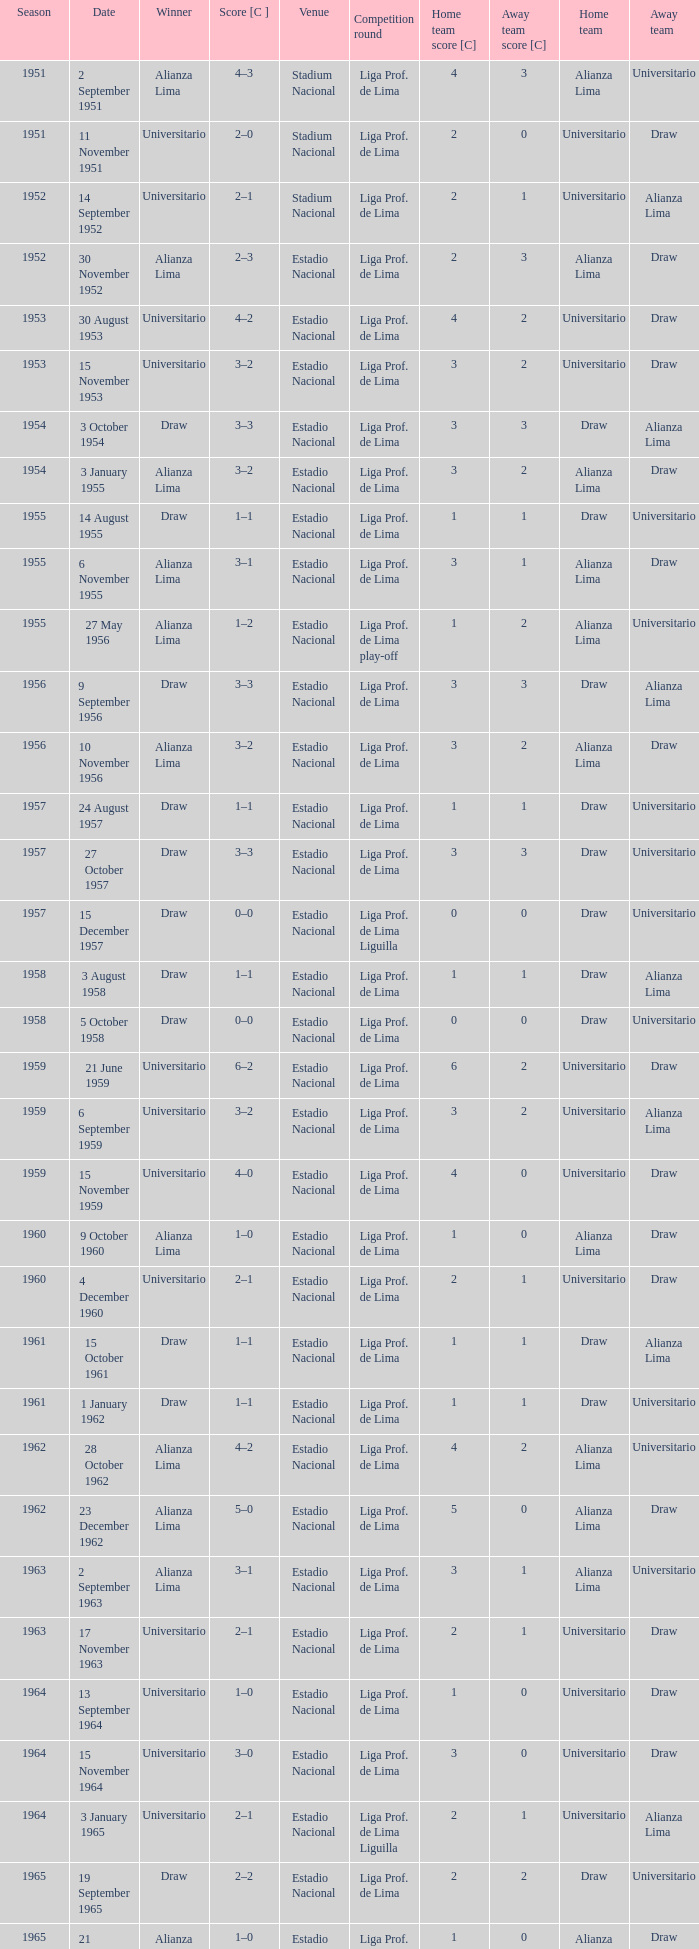I'm looking to parse the entire table for insights. Could you assist me with that? {'header': ['Season', 'Date', 'Winner', 'Score [C ]', 'Venue', 'Competition round', 'Home team score [C]', 'Away team score [C]', 'Home team', 'Away team'], 'rows': [['1951', '2 September 1951', 'Alianza Lima', '4–3', 'Stadium Nacional', 'Liga Prof. de Lima', '4', '3', 'Alianza Lima', 'Universitario'], ['1951', '11 November 1951', 'Universitario', '2–0', 'Stadium Nacional', 'Liga Prof. de Lima', '2', '0', 'Universitario', 'Draw'], ['1952', '14 September 1952', 'Universitario', '2–1', 'Stadium Nacional', 'Liga Prof. de Lima', '2', '1', 'Universitario', 'Alianza Lima'], ['1952', '30 November 1952', 'Alianza Lima', '2–3', 'Estadio Nacional', 'Liga Prof. de Lima', '2', '3', 'Alianza Lima', 'Draw'], ['1953', '30 August 1953', 'Universitario', '4–2', 'Estadio Nacional', 'Liga Prof. de Lima', '4', '2', 'Universitario', 'Draw'], ['1953', '15 November 1953', 'Universitario', '3–2', 'Estadio Nacional', 'Liga Prof. de Lima', '3', '2', 'Universitario', 'Draw'], ['1954', '3 October 1954', 'Draw', '3–3', 'Estadio Nacional', 'Liga Prof. de Lima', '3', '3', 'Draw', 'Alianza Lima'], ['1954', '3 January 1955', 'Alianza Lima', '3–2', 'Estadio Nacional', 'Liga Prof. de Lima', '3', '2', 'Alianza Lima', 'Draw'], ['1955', '14 August 1955', 'Draw', '1–1', 'Estadio Nacional', 'Liga Prof. de Lima', '1', '1', 'Draw', 'Universitario'], ['1955', '6 November 1955', 'Alianza Lima', '3–1', 'Estadio Nacional', 'Liga Prof. de Lima', '3', '1', 'Alianza Lima', 'Draw'], ['1955', '27 May 1956', 'Alianza Lima', '1–2', 'Estadio Nacional', 'Liga Prof. de Lima play-off', '1', '2', 'Alianza Lima', 'Universitario'], ['1956', '9 September 1956', 'Draw', '3–3', 'Estadio Nacional', 'Liga Prof. de Lima', '3', '3', 'Draw', 'Alianza Lima'], ['1956', '10 November 1956', 'Alianza Lima', '3–2', 'Estadio Nacional', 'Liga Prof. de Lima', '3', '2', 'Alianza Lima', 'Draw'], ['1957', '24 August 1957', 'Draw', '1–1', 'Estadio Nacional', 'Liga Prof. de Lima', '1', '1', 'Draw', 'Universitario'], ['1957', '27 October 1957', 'Draw', '3–3', 'Estadio Nacional', 'Liga Prof. de Lima', '3', '3', 'Draw', 'Universitario'], ['1957', '15 December 1957', 'Draw', '0–0', 'Estadio Nacional', 'Liga Prof. de Lima Liguilla', '0', '0', 'Draw', 'Universitario'], ['1958', '3 August 1958', 'Draw', '1–1', 'Estadio Nacional', 'Liga Prof. de Lima', '1', '1', 'Draw', 'Alianza Lima'], ['1958', '5 October 1958', 'Draw', '0–0', 'Estadio Nacional', 'Liga Prof. de Lima', '0', '0', 'Draw', 'Universitario'], ['1959', '21 June 1959', 'Universitario', '6–2', 'Estadio Nacional', 'Liga Prof. de Lima', '6', '2', 'Universitario', 'Draw'], ['1959', '6 September 1959', 'Universitario', '3–2', 'Estadio Nacional', 'Liga Prof. de Lima', '3', '2', 'Universitario', 'Alianza Lima'], ['1959', '15 November 1959', 'Universitario', '4–0', 'Estadio Nacional', 'Liga Prof. de Lima', '4', '0', 'Universitario', 'Draw'], ['1960', '9 October 1960', 'Alianza Lima', '1–0', 'Estadio Nacional', 'Liga Prof. de Lima', '1', '0', 'Alianza Lima', 'Draw'], ['1960', '4 December 1960', 'Universitario', '2–1', 'Estadio Nacional', 'Liga Prof. de Lima', '2', '1', 'Universitario', 'Draw'], ['1961', '15 October 1961', 'Draw', '1–1', 'Estadio Nacional', 'Liga Prof. de Lima', '1', '1', 'Draw', 'Alianza Lima'], ['1961', '1 January 1962', 'Draw', '1–1', 'Estadio Nacional', 'Liga Prof. de Lima', '1', '1', 'Draw', 'Universitario'], ['1962', '28 October 1962', 'Alianza Lima', '4–2', 'Estadio Nacional', 'Liga Prof. de Lima', '4', '2', 'Alianza Lima', 'Universitario'], ['1962', '23 December 1962', 'Alianza Lima', '5–0', 'Estadio Nacional', 'Liga Prof. de Lima', '5', '0', 'Alianza Lima', 'Draw'], ['1963', '2 September 1963', 'Alianza Lima', '3–1', 'Estadio Nacional', 'Liga Prof. de Lima', '3', '1', 'Alianza Lima', 'Universitario'], ['1963', '17 November 1963', 'Universitario', '2–1', 'Estadio Nacional', 'Liga Prof. de Lima', '2', '1', 'Universitario', 'Draw'], ['1964', '13 September 1964', 'Universitario', '1–0', 'Estadio Nacional', 'Liga Prof. de Lima', '1', '0', 'Universitario', 'Draw'], ['1964', '15 November 1964', 'Universitario', '3–0', 'Estadio Nacional', 'Liga Prof. de Lima', '3', '0', 'Universitario', 'Draw'], ['1964', '3 January 1965', 'Universitario', '2–1', 'Estadio Nacional', 'Liga Prof. de Lima Liguilla', '2', '1', 'Universitario', 'Alianza Lima'], ['1965', '19 September 1965', 'Draw', '2–2', 'Estadio Nacional', 'Liga Prof. de Lima', '2', '2', 'Draw', 'Universitario'], ['1965', '21 November 1965', 'Alianza Lima', '1–0', 'Estadio Nacional', 'Liga Prof. de Lima', '1', '0', 'Alianza Lima', 'Draw'], ['1965', '19 December 1965', 'Universitario', '1–0', 'Estadio Nacional', 'Liga Prof. de Lima Liguilla', '1', '0', 'Universitario', 'Alianza Lima']]} What venue had an event on 17 November 1963? Estadio Nacional. 